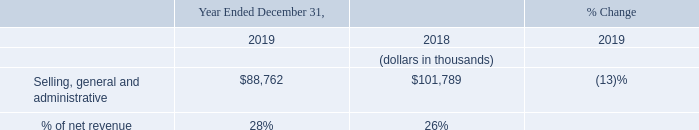Selling, General and Administrative
Selling, general and administrative expense decreased $13.0 million to $88.8 million for the year ended December 31, 2019, as compared to $101.8 million for the year ended December 31, 2018. The decrease was primarily due to a decrease in intangible asset amortization of $8.9 million as certain assets reached the end of their useful lives, as well as decreases in payroll-related expense of $1.7 million due to lower headcount, professional fees of $1.3 million, outside services of $0.5 million, and travel-related expenses of $0.3 million.
We expect selling, general and administrative expenses to remain relatively flat in the near-term; however, our expenses may increase in the future as we expand our sales and marketing organization to enable market expansion.
Why is the selling, general and administrative expenses expected to increase in the future? As we expand our sales and marketing organization to enable market expansion. What is the average Selling, general and administrative for the Years Ended December 31, 2019 to 2018?
Answer scale should be: thousand. (88,762+101,789) / 2
Answer: 95275.5. What is the average % of net revenue for the Years Ended December 31, 2019 to 2018?
Answer scale should be: percent. (28+26) / 2
Answer: 27. In which year was Selling, general and administrative less than 100,000 thousands? Locate and analyze selling, general and administrative in row 4
answer: 2019. What was the respective % of net revenue in 2019 and 2018? 28%, 26%. What was the decrease in Selling, general and administrative in 2019? $13.0 million. 